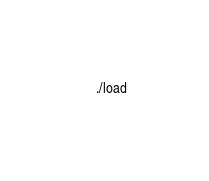Convert code to text. <code><loc_0><loc_0><loc_500><loc_500><_Bash_>    ./load
</code> 